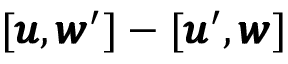<formula> <loc_0><loc_0><loc_500><loc_500>[ { \pm b u } , { \pm b w } ^ { \prime } ] - [ { \pm b u } ^ { \prime } , { \pm b w } ]</formula> 